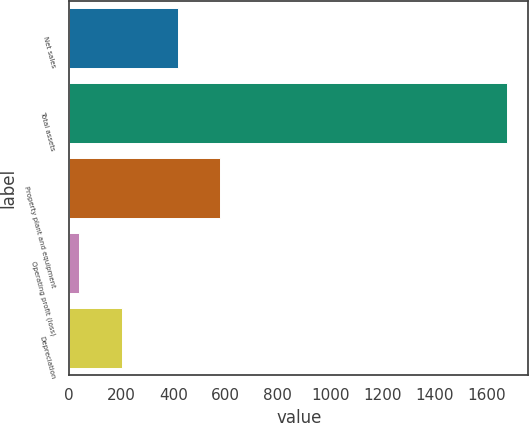Convert chart. <chart><loc_0><loc_0><loc_500><loc_500><bar_chart><fcel>Net sales<fcel>Total assets<fcel>Property plant and equipment<fcel>Operating profit (loss)<fcel>Depreciation<nl><fcel>416<fcel>1676<fcel>579.6<fcel>40<fcel>203.6<nl></chart> 